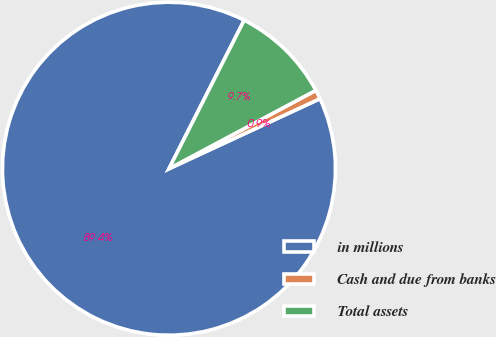Convert chart to OTSL. <chart><loc_0><loc_0><loc_500><loc_500><pie_chart><fcel>in millions<fcel>Cash and due from banks<fcel>Total assets<nl><fcel>89.38%<fcel>0.89%<fcel>9.74%<nl></chart> 